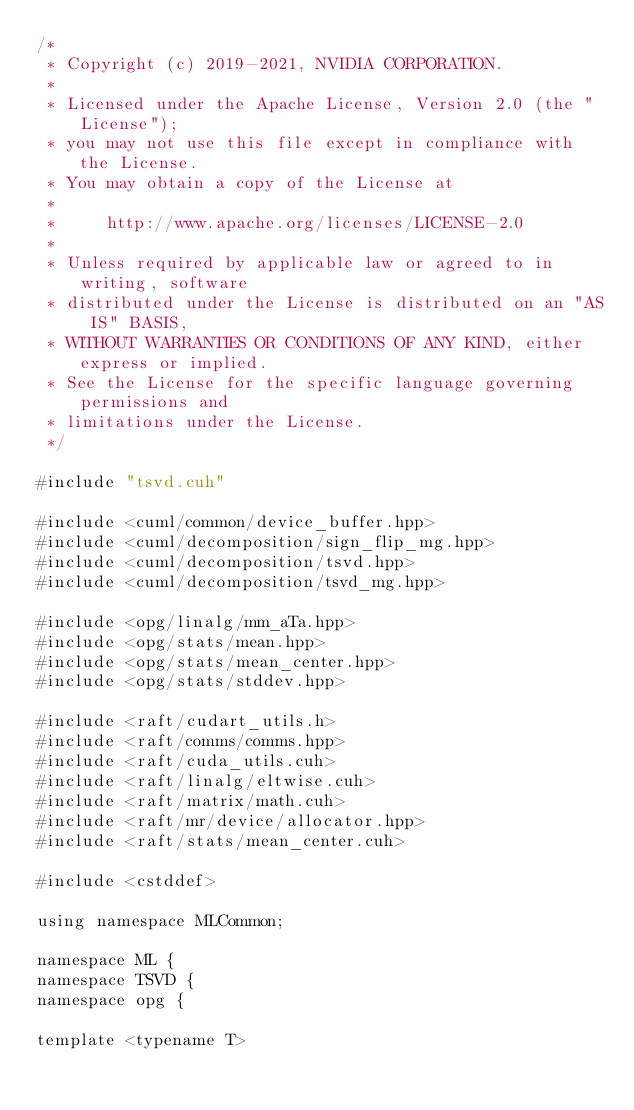<code> <loc_0><loc_0><loc_500><loc_500><_Cuda_>/*
 * Copyright (c) 2019-2021, NVIDIA CORPORATION.
 *
 * Licensed under the Apache License, Version 2.0 (the "License");
 * you may not use this file except in compliance with the License.
 * You may obtain a copy of the License at
 *
 *     http://www.apache.org/licenses/LICENSE-2.0
 *
 * Unless required by applicable law or agreed to in writing, software
 * distributed under the License is distributed on an "AS IS" BASIS,
 * WITHOUT WARRANTIES OR CONDITIONS OF ANY KIND, either express or implied.
 * See the License for the specific language governing permissions and
 * limitations under the License.
 */

#include "tsvd.cuh"

#include <cuml/common/device_buffer.hpp>
#include <cuml/decomposition/sign_flip_mg.hpp>
#include <cuml/decomposition/tsvd.hpp>
#include <cuml/decomposition/tsvd_mg.hpp>

#include <opg/linalg/mm_aTa.hpp>
#include <opg/stats/mean.hpp>
#include <opg/stats/mean_center.hpp>
#include <opg/stats/stddev.hpp>

#include <raft/cudart_utils.h>
#include <raft/comms/comms.hpp>
#include <raft/cuda_utils.cuh>
#include <raft/linalg/eltwise.cuh>
#include <raft/matrix/math.cuh>
#include <raft/mr/device/allocator.hpp>
#include <raft/stats/mean_center.cuh>

#include <cstddef>

using namespace MLCommon;

namespace ML {
namespace TSVD {
namespace opg {

template <typename T></code> 